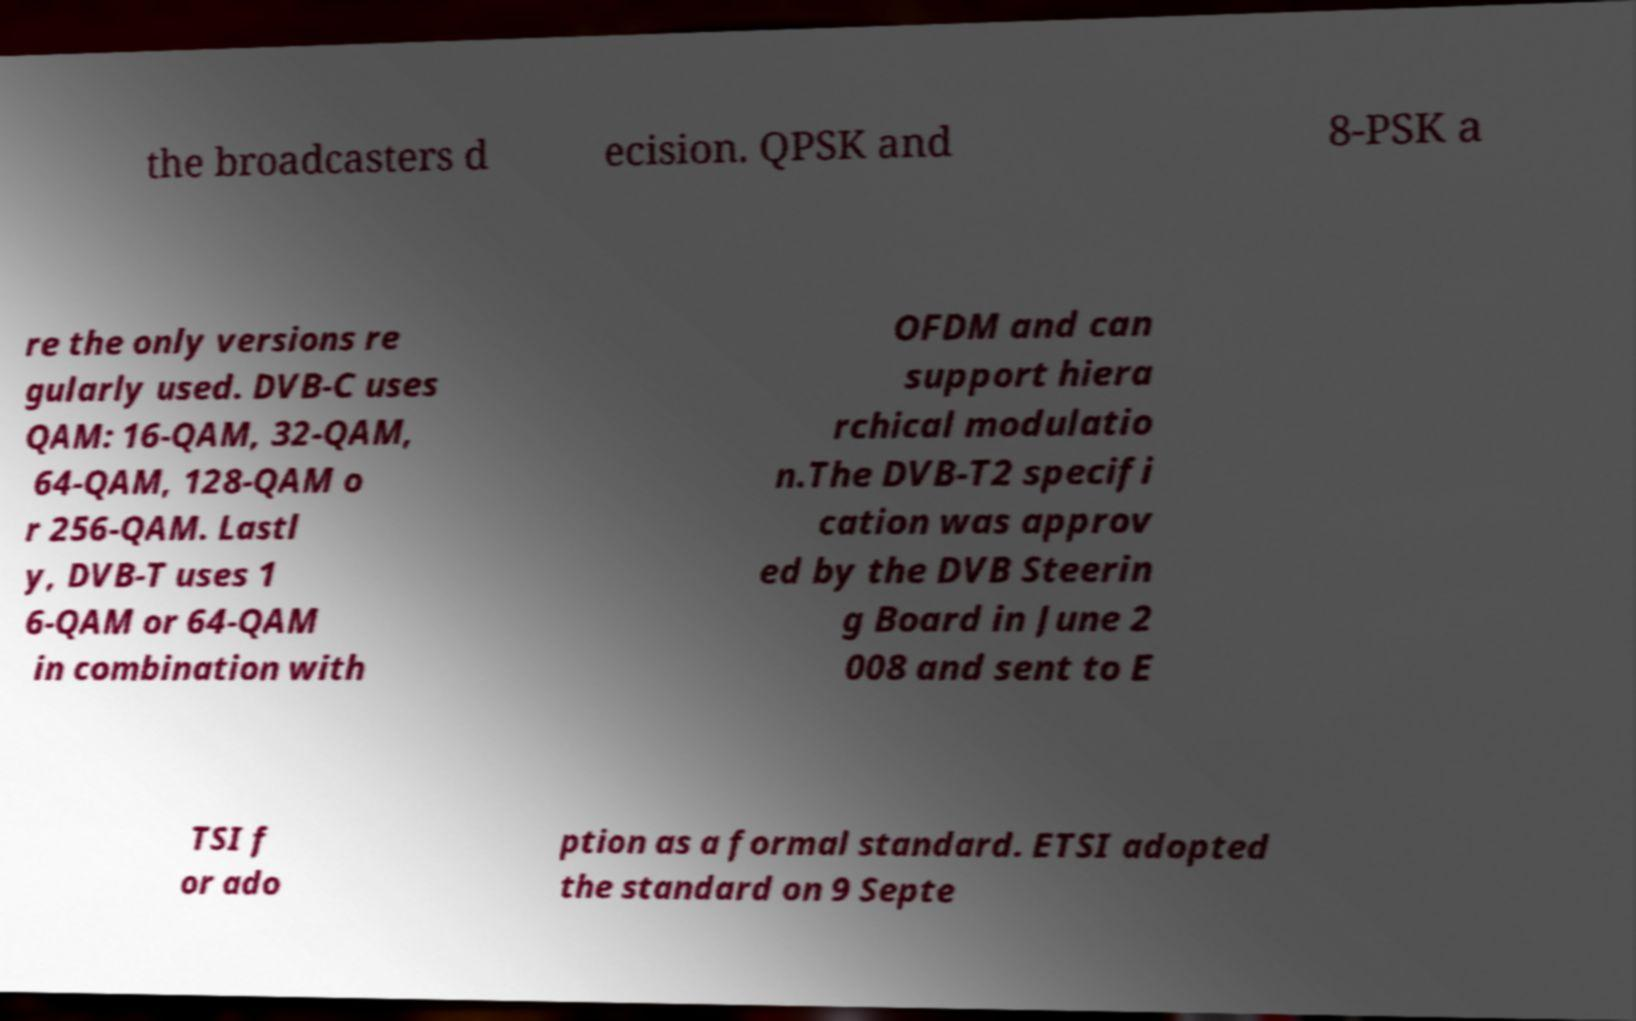What messages or text are displayed in this image? I need them in a readable, typed format. the broadcasters d ecision. QPSK and 8-PSK a re the only versions re gularly used. DVB-C uses QAM: 16-QAM, 32-QAM, 64-QAM, 128-QAM o r 256-QAM. Lastl y, DVB-T uses 1 6-QAM or 64-QAM in combination with OFDM and can support hiera rchical modulatio n.The DVB-T2 specifi cation was approv ed by the DVB Steerin g Board in June 2 008 and sent to E TSI f or ado ption as a formal standard. ETSI adopted the standard on 9 Septe 